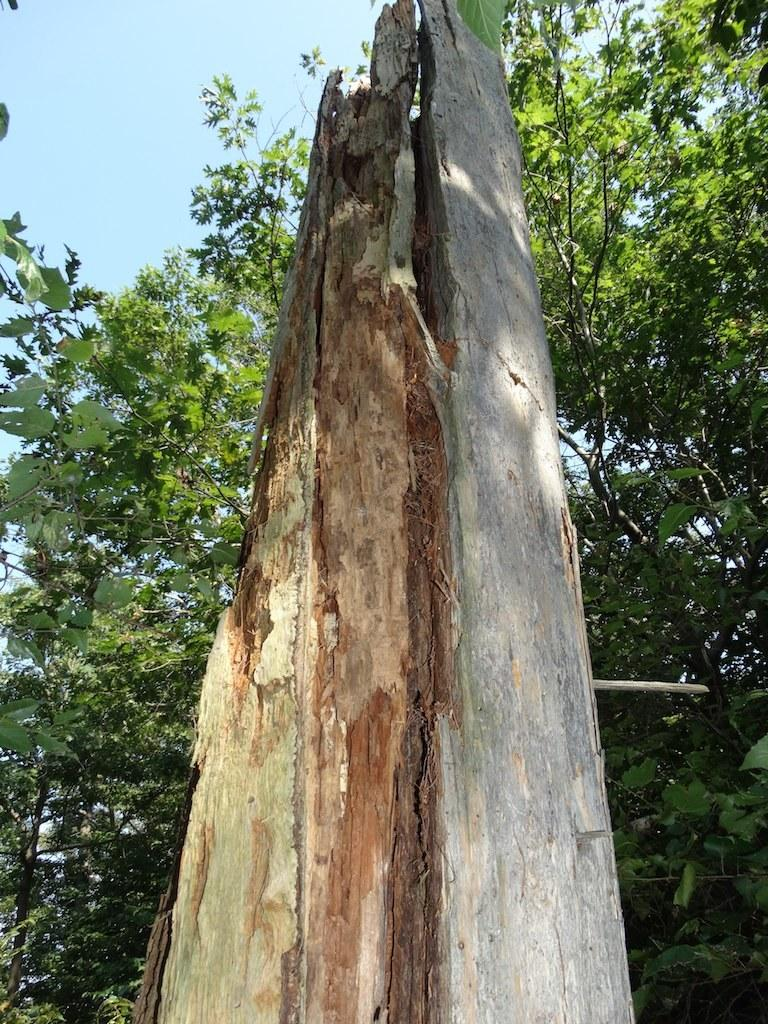What is the main object in the center of the image? There is a wood log in the center of the image. What can be seen in the background of the image? There are trees visible in the background of the image. What is visible at the top of the image? The sky is visible at the top of the image. What type of copper material can be seen in the image? There is no copper material present in the image. How does the wood log contribute to the health of the trees in the background? The image does not provide information about the health of the trees or any relationship between the wood log and the trees. 